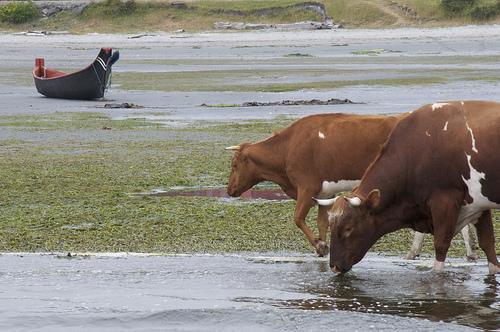How many cows are there?
Give a very brief answer. 2. 